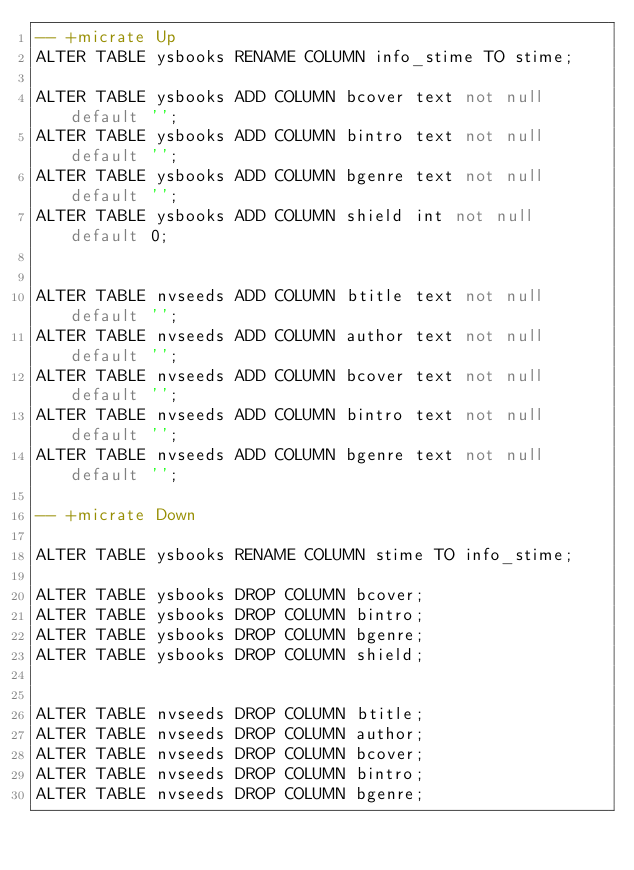<code> <loc_0><loc_0><loc_500><loc_500><_SQL_>-- +micrate Up
ALTER TABLE ysbooks RENAME COLUMN info_stime TO stime;

ALTER TABLE ysbooks ADD COLUMN bcover text not null default '';
ALTER TABLE ysbooks ADD COLUMN bintro text not null default '';
ALTER TABLE ysbooks ADD COLUMN bgenre text not null default '';
ALTER TABLE ysbooks ADD COLUMN shield int not null default 0;


ALTER TABLE nvseeds ADD COLUMN btitle text not null default '';
ALTER TABLE nvseeds ADD COLUMN author text not null default '';
ALTER TABLE nvseeds ADD COLUMN bcover text not null default '';
ALTER TABLE nvseeds ADD COLUMN bintro text not null default '';
ALTER TABLE nvseeds ADD COLUMN bgenre text not null default '';

-- +micrate Down

ALTER TABLE ysbooks RENAME COLUMN stime TO info_stime;

ALTER TABLE ysbooks DROP COLUMN bcover;
ALTER TABLE ysbooks DROP COLUMN bintro;
ALTER TABLE ysbooks DROP COLUMN bgenre;
ALTER TABLE ysbooks DROP COLUMN shield;


ALTER TABLE nvseeds DROP COLUMN btitle;
ALTER TABLE nvseeds DROP COLUMN author;
ALTER TABLE nvseeds DROP COLUMN bcover;
ALTER TABLE nvseeds DROP COLUMN bintro;
ALTER TABLE nvseeds DROP COLUMN bgenre;
</code> 